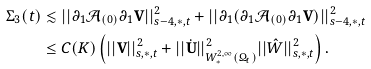Convert formula to latex. <formula><loc_0><loc_0><loc_500><loc_500>\Sigma _ { 3 } ( t ) & \lesssim | | \partial _ { 1 } \mathcal { A } _ { ( 0 ) } \partial _ { 1 } { \mathbf V } | | ^ { 2 } _ { s - 4 , \ast , t } + | | \partial _ { 1 } ( \partial _ { 1 } \mathcal { A } _ { ( 0 ) } \partial _ { 1 } { \mathbf V } ) | | ^ { 2 } _ { s - 4 , \ast , t } \\ & \leq C ( K ) \left ( | | { \mathbf V } | | ^ { 2 } _ { s , \ast , t } + | | \dot { \mathbf U } | | ^ { 2 } _ { W ^ { 2 , \infty } _ { \ast } ( \Omega _ { t } ) } | | \hat { W } | | ^ { 2 } _ { s , \ast , t } \right ) .</formula> 